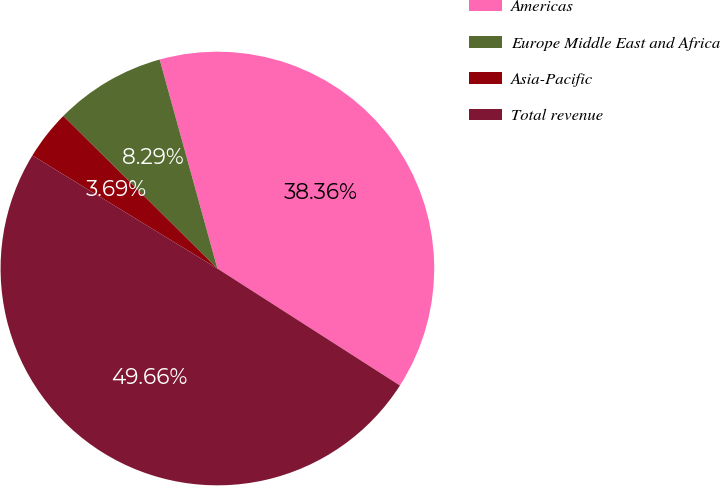<chart> <loc_0><loc_0><loc_500><loc_500><pie_chart><fcel>Americas<fcel>Europe Middle East and Africa<fcel>Asia-Pacific<fcel>Total revenue<nl><fcel>38.36%<fcel>8.29%<fcel>3.69%<fcel>49.66%<nl></chart> 